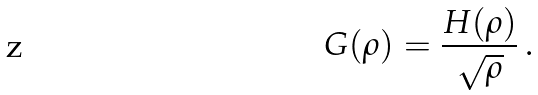Convert formula to latex. <formula><loc_0><loc_0><loc_500><loc_500>G ( \rho ) = { \frac { H ( \rho ) } { \sqrt { \rho } } } \, .</formula> 